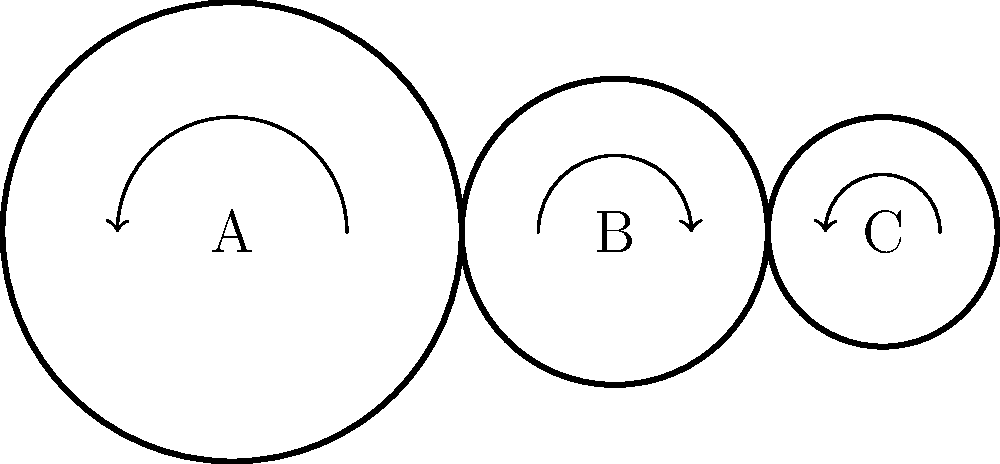In the gear arrangement shown above, gear A has 30 teeth, gear B has 20 teeth, and gear C has 15 teeth. If gear A rotates at 60 RPM (revolutions per minute) clockwise, what is the speed and direction of rotation of gear C? To solve this problem, we'll follow these steps:

1. Determine the gear ratios:
   - Between A and B: $\frac{\text{Teeth}_A}{\text{Teeth}_B} = \frac{30}{20} = 1.5$
   - Between B and C: $\frac{\text{Teeth}_B}{\text{Teeth}_C} = \frac{20}{15} = \frac{4}{3}$

2. Calculate the speed of gear B:
   - Speed of B = Speed of A × Gear ratio (A to B)
   - Speed of B = 60 RPM × $\frac{30}{20} = 90$ RPM

3. Calculate the speed of gear C:
   - Speed of C = Speed of B × Gear ratio (B to C)
   - Speed of C = 90 RPM × $\frac{20}{15} = 120$ RPM

4. Determine the direction of rotation:
   - Gear A rotates clockwise
   - Gear B rotates counterclockwise (opposite to A)
   - Gear C rotates clockwise (opposite to B)

Therefore, gear C rotates at 120 RPM in the clockwise direction.
Answer: 120 RPM clockwise 